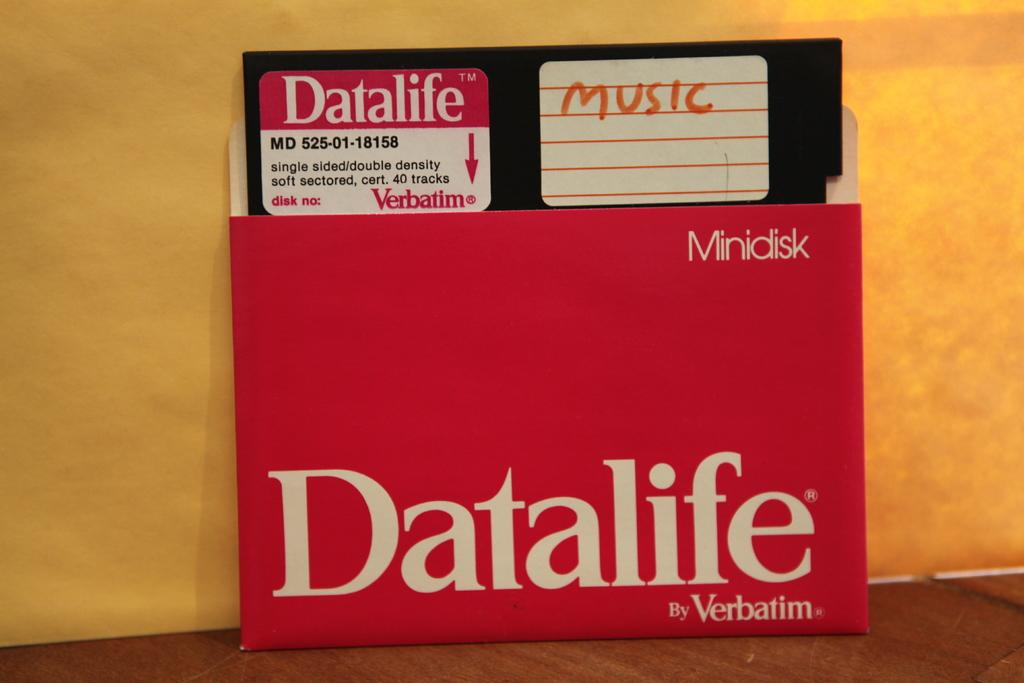<image>
Create a compact narrative representing the image presented. A Datalife brand floppy disc that has the word music written on it. 